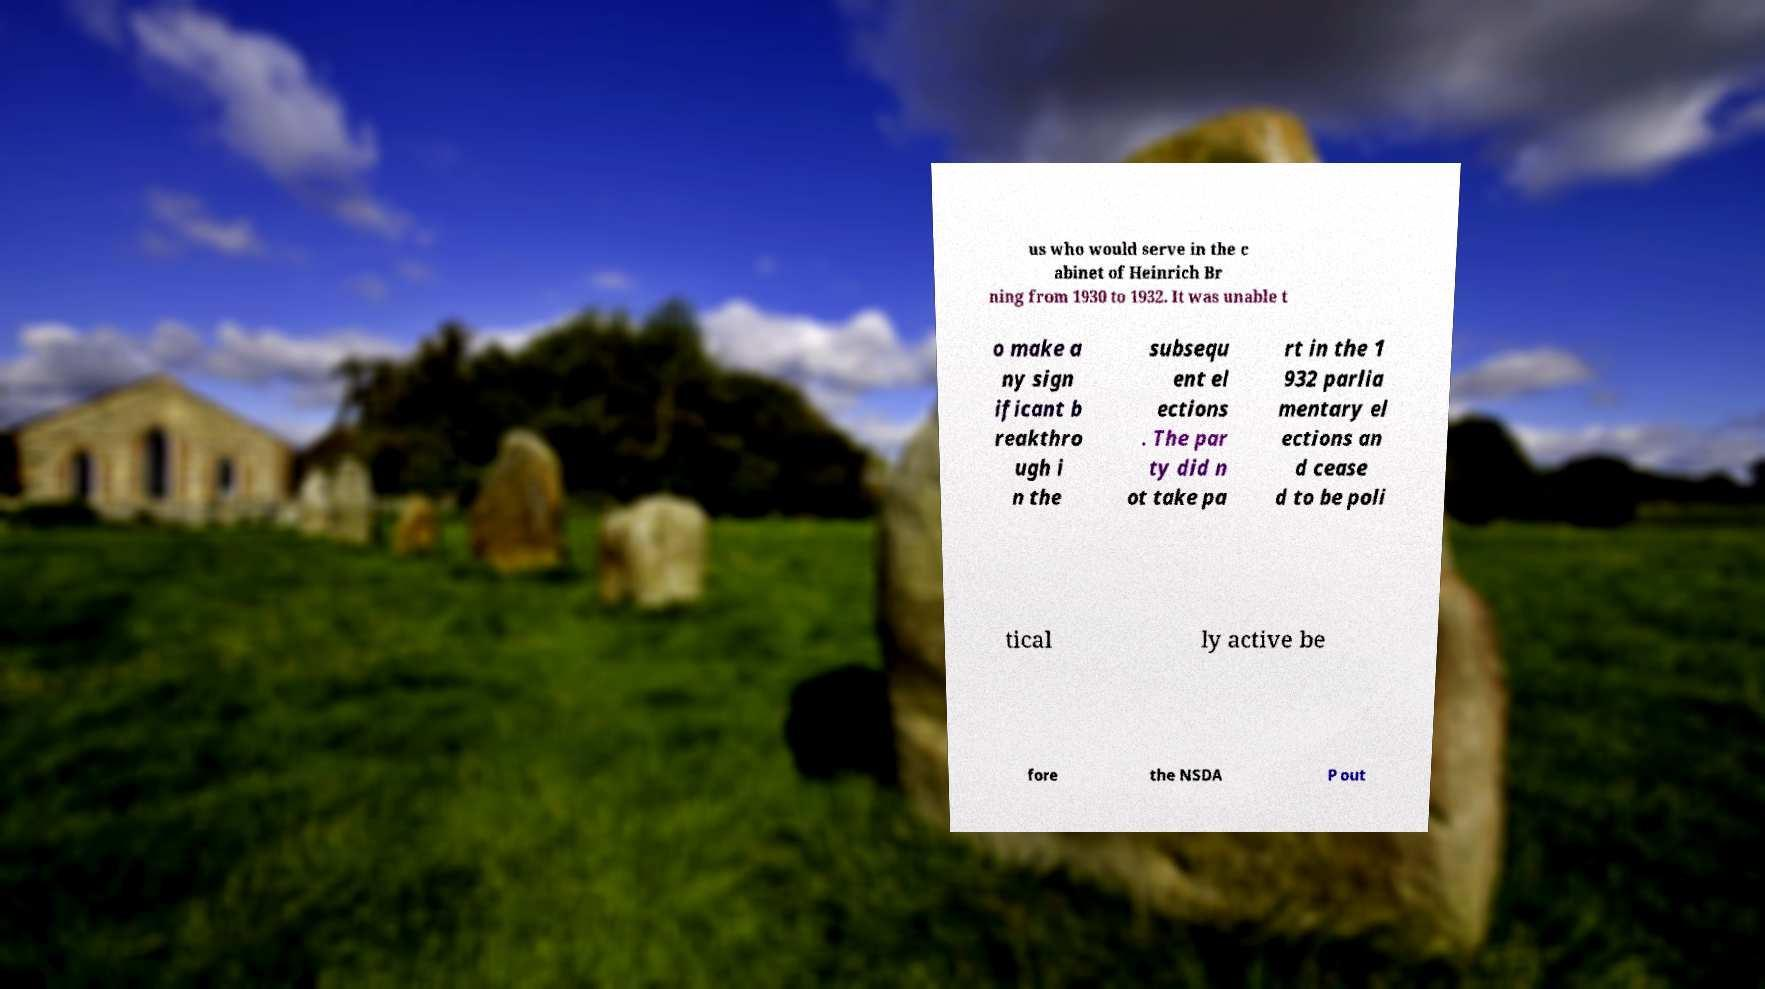Please read and relay the text visible in this image. What does it say? us who would serve in the c abinet of Heinrich Br ning from 1930 to 1932. It was unable t o make a ny sign ificant b reakthro ugh i n the subsequ ent el ections . The par ty did n ot take pa rt in the 1 932 parlia mentary el ections an d cease d to be poli tical ly active be fore the NSDA P out 